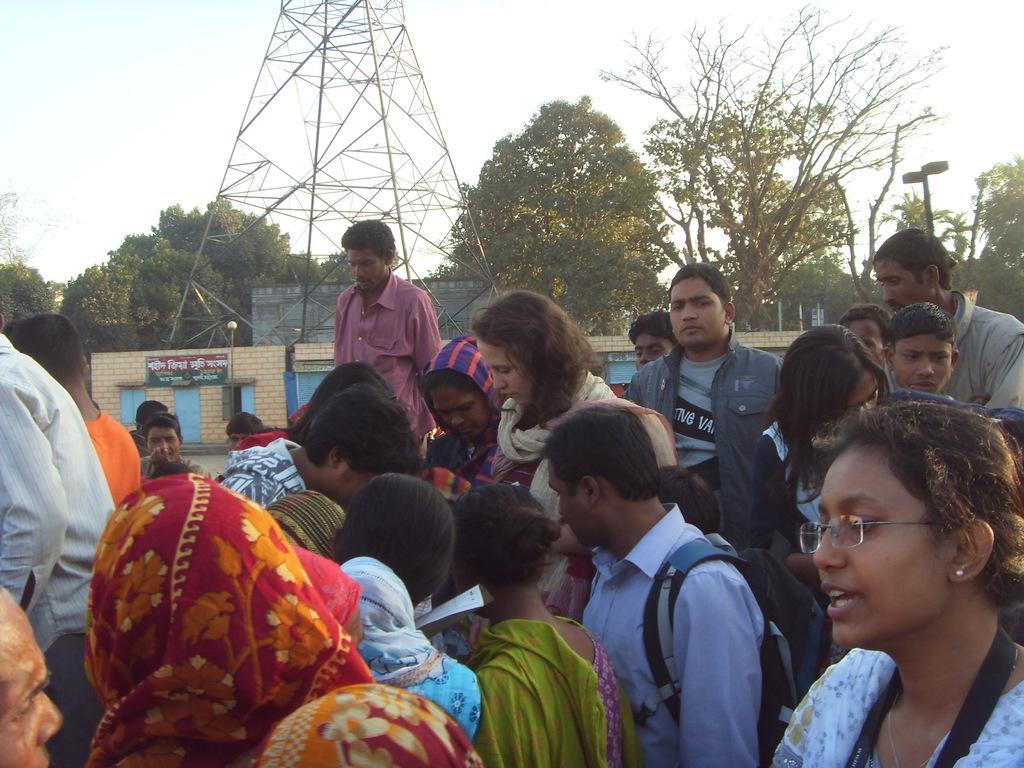Could you give a brief overview of what you see in this image? In this image there is the sky towards the top of the image, there is a tower towards the top of the image, there are trees, there is a wall, there are windows, there is a door, there is aboard, there is text on the boards, there are poles, there are streetlights, there are persons towards the bottom of the image, they are holding an object, there is a man wearing the bag. 